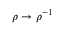<formula> <loc_0><loc_0><loc_500><loc_500>\rho \to \rho ^ { - 1 }</formula> 